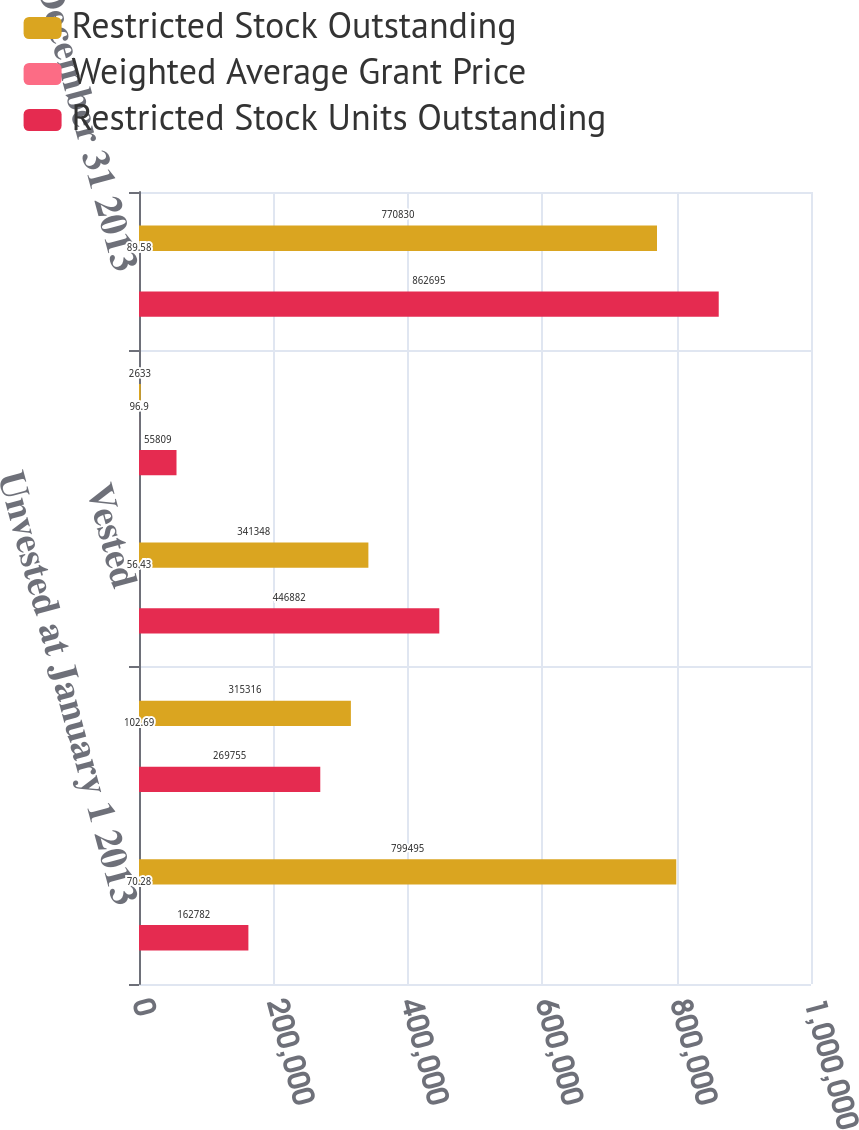Convert chart. <chart><loc_0><loc_0><loc_500><loc_500><stacked_bar_chart><ecel><fcel>Unvested at January 1 2013<fcel>Granted<fcel>Vested<fcel>Cancelled<fcel>Unvested at December 31 2013<nl><fcel>Restricted Stock Outstanding<fcel>799495<fcel>315316<fcel>341348<fcel>2633<fcel>770830<nl><fcel>Weighted Average Grant Price<fcel>70.28<fcel>102.69<fcel>56.43<fcel>96.9<fcel>89.58<nl><fcel>Restricted Stock Units Outstanding<fcel>162782<fcel>269755<fcel>446882<fcel>55809<fcel>862695<nl></chart> 